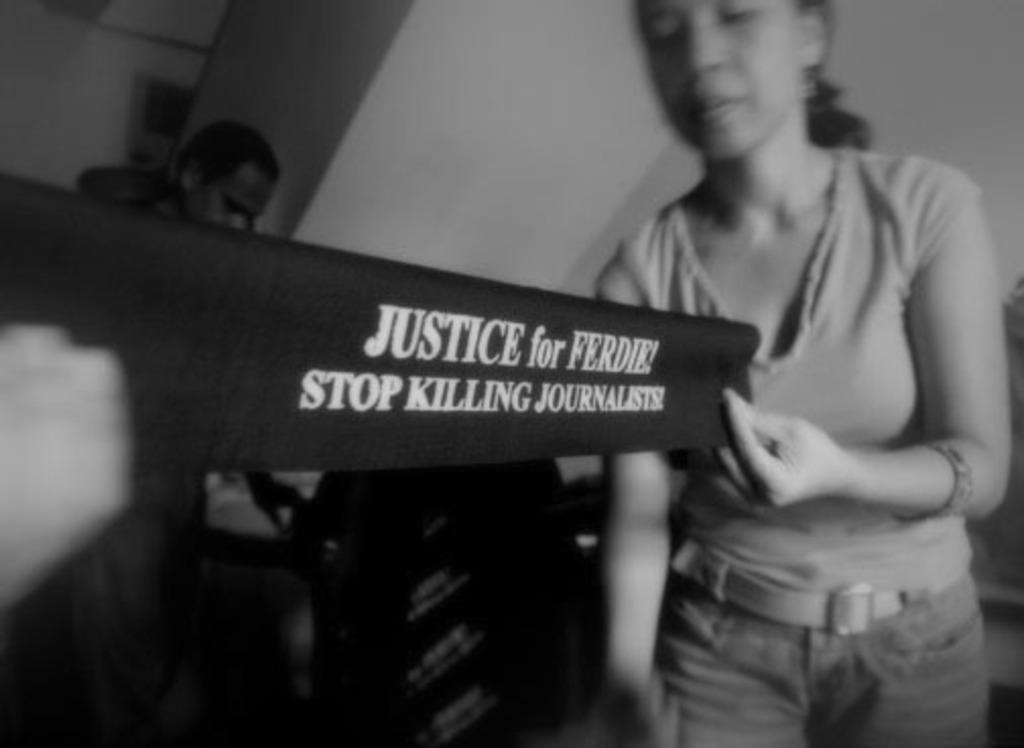In one or two sentences, can you explain what this image depicts? In this image I can see two persons and here I can see she is holding a black colour thing. I can also see something is written over here and I can see this image is black and white in colour. 